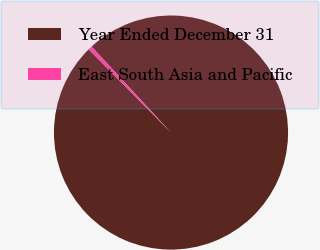<chart> <loc_0><loc_0><loc_500><loc_500><pie_chart><fcel>Year Ended December 31<fcel>East South Asia and Pacific<nl><fcel>99.45%<fcel>0.55%<nl></chart> 